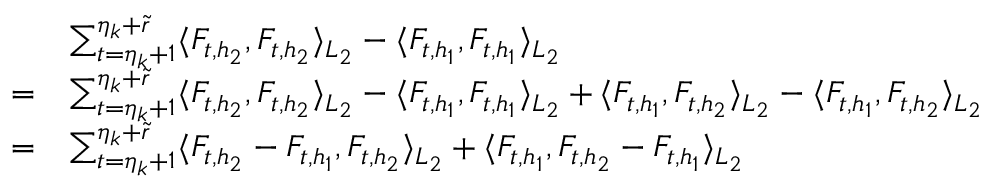<formula> <loc_0><loc_0><loc_500><loc_500>\begin{array} { r l } & { \sum _ { t = \eta _ { k } + 1 } ^ { \eta _ { k } + \widetilde { r } } \langle F _ { t , h _ { 2 } } , F _ { t , h _ { 2 } } \rangle _ { L _ { 2 } } - \langle F _ { t , h _ { 1 } } , F _ { t , h _ { 1 } } \rangle _ { L _ { 2 } } } \\ { = } & { \sum _ { t = \eta _ { k } + 1 } ^ { \eta _ { k } + \widetilde { r } } \langle F _ { t , h _ { 2 } } , F _ { t , h _ { 2 } } \rangle _ { L _ { 2 } } - \langle F _ { t , h _ { 1 } } , F _ { t , h _ { 1 } } \rangle _ { L _ { 2 } } + \langle F _ { t , h _ { 1 } } , F _ { t , h _ { 2 } } \rangle _ { L _ { 2 } } - \langle F _ { t , h _ { 1 } } , F _ { t , h _ { 2 } } \rangle _ { L _ { 2 } } } \\ { = } & { \sum _ { t = \eta _ { k } + 1 } ^ { \eta _ { k } + \widetilde { r } } \langle F _ { t , h _ { 2 } } - F _ { t , h _ { 1 } } , F _ { t , h _ { 2 } } \rangle _ { L _ { 2 } } + \langle F _ { t , h _ { 1 } } , F _ { t , h _ { 2 } } - F _ { t , h _ { 1 } } \rangle _ { L _ { 2 } } } \end{array}</formula> 